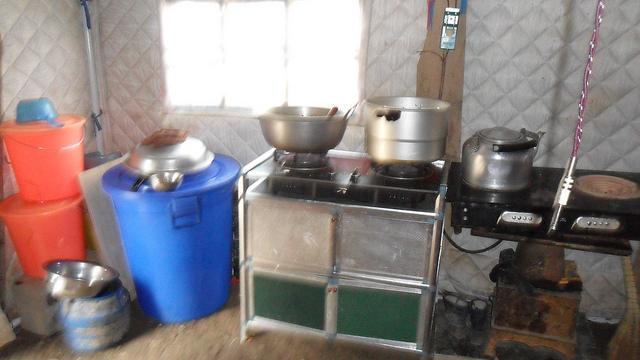How many ovens are there?
Give a very brief answer. 1. How many bowls are visible?
Give a very brief answer. 2. 